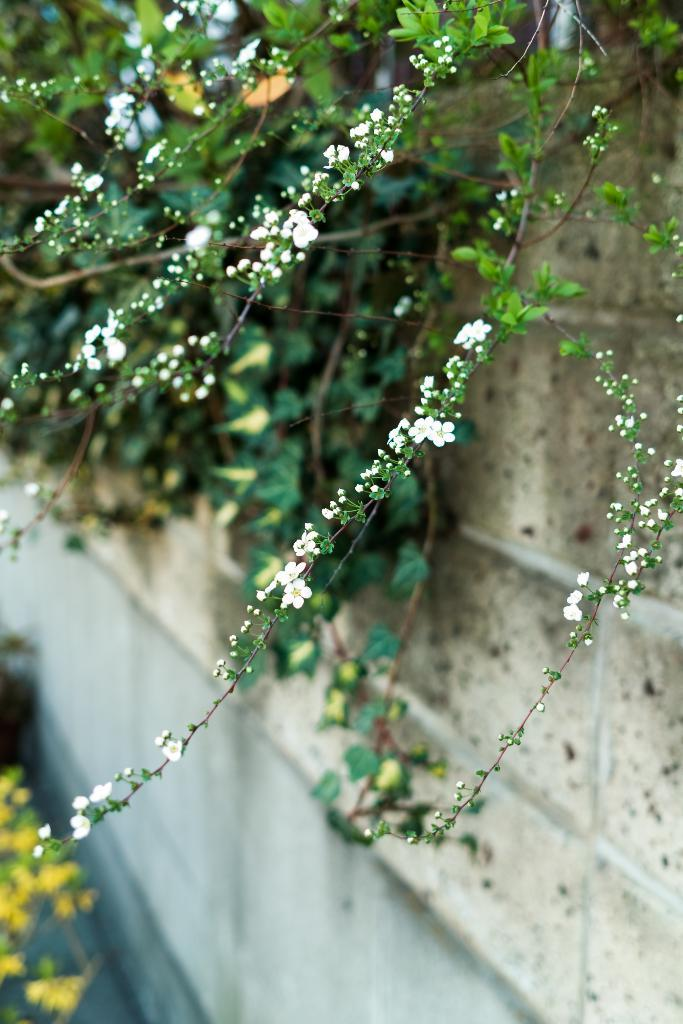What colors are the flowers in the image? The flowers in the image are in white and yellow colors. What color are the plants in the image? The plants in the image are in green color. What color is the wall in the image? The wall in the image is in cream color. How many cats are sitting on the wall in the image? There are no cats present in the image; it features flowers, plants, and a wall. What type of advertisement can be seen on the wall in the image? There is no advertisement present on the wall in the image; it is a plain cream-colored wall. 